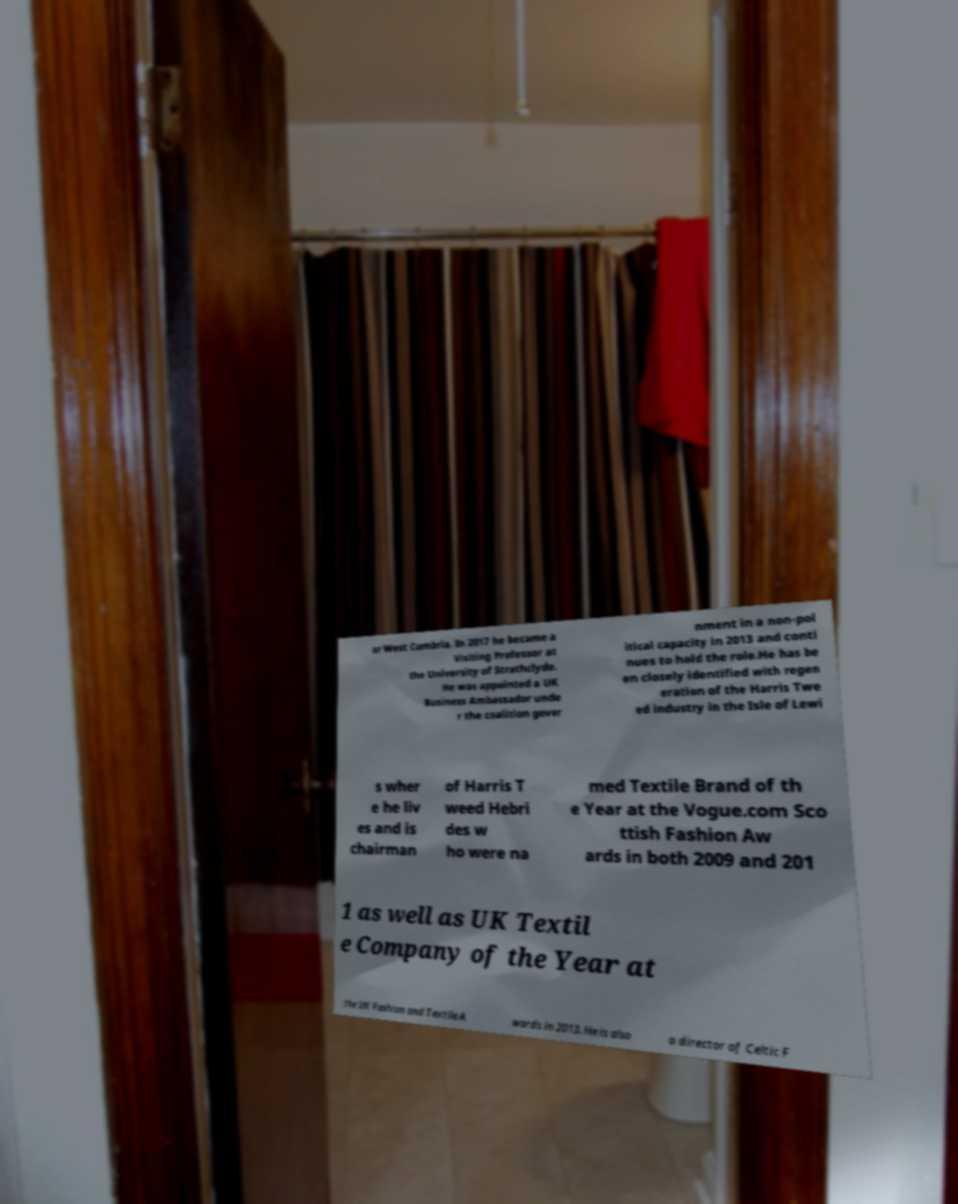Can you accurately transcribe the text from the provided image for me? or West Cumbria. In 2017 he became a Visiting Professor at the University of Strathclyde. He was appointed a UK Business Ambassador unde r the coalition gover nment in a non-pol itical capacity in 2013 and conti nues to hold the role.He has be en closely identified with regen eration of the Harris Twe ed industry in the Isle of Lewi s wher e he liv es and is chairman of Harris T weed Hebri des w ho were na med Textile Brand of th e Year at the Vogue.com Sco ttish Fashion Aw ards in both 2009 and 201 1 as well as UK Textil e Company of the Year at the UK Fashion and Textile A wards in 2013. He is also a director of Celtic F 